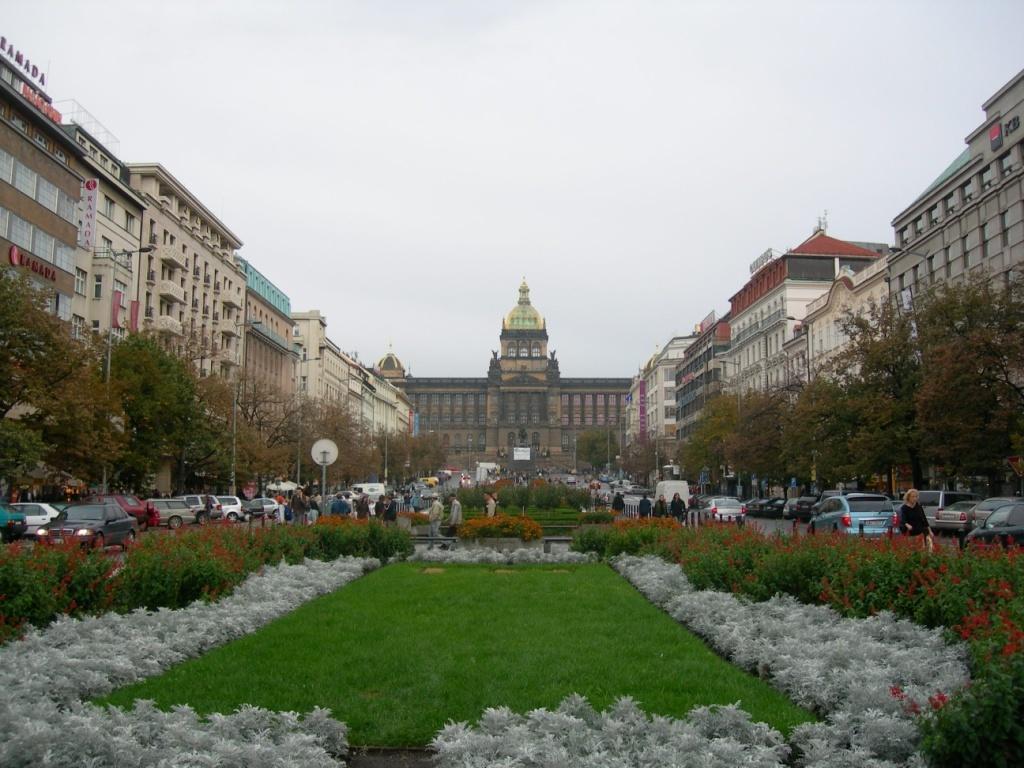In one or two sentences, can you explain what this image depicts? In this image we can see the persons walking and there are vehicles parked on the road. We can see the buildings, poles, trees, board, grass and plants with flowers. In the background, we can see the sky. 